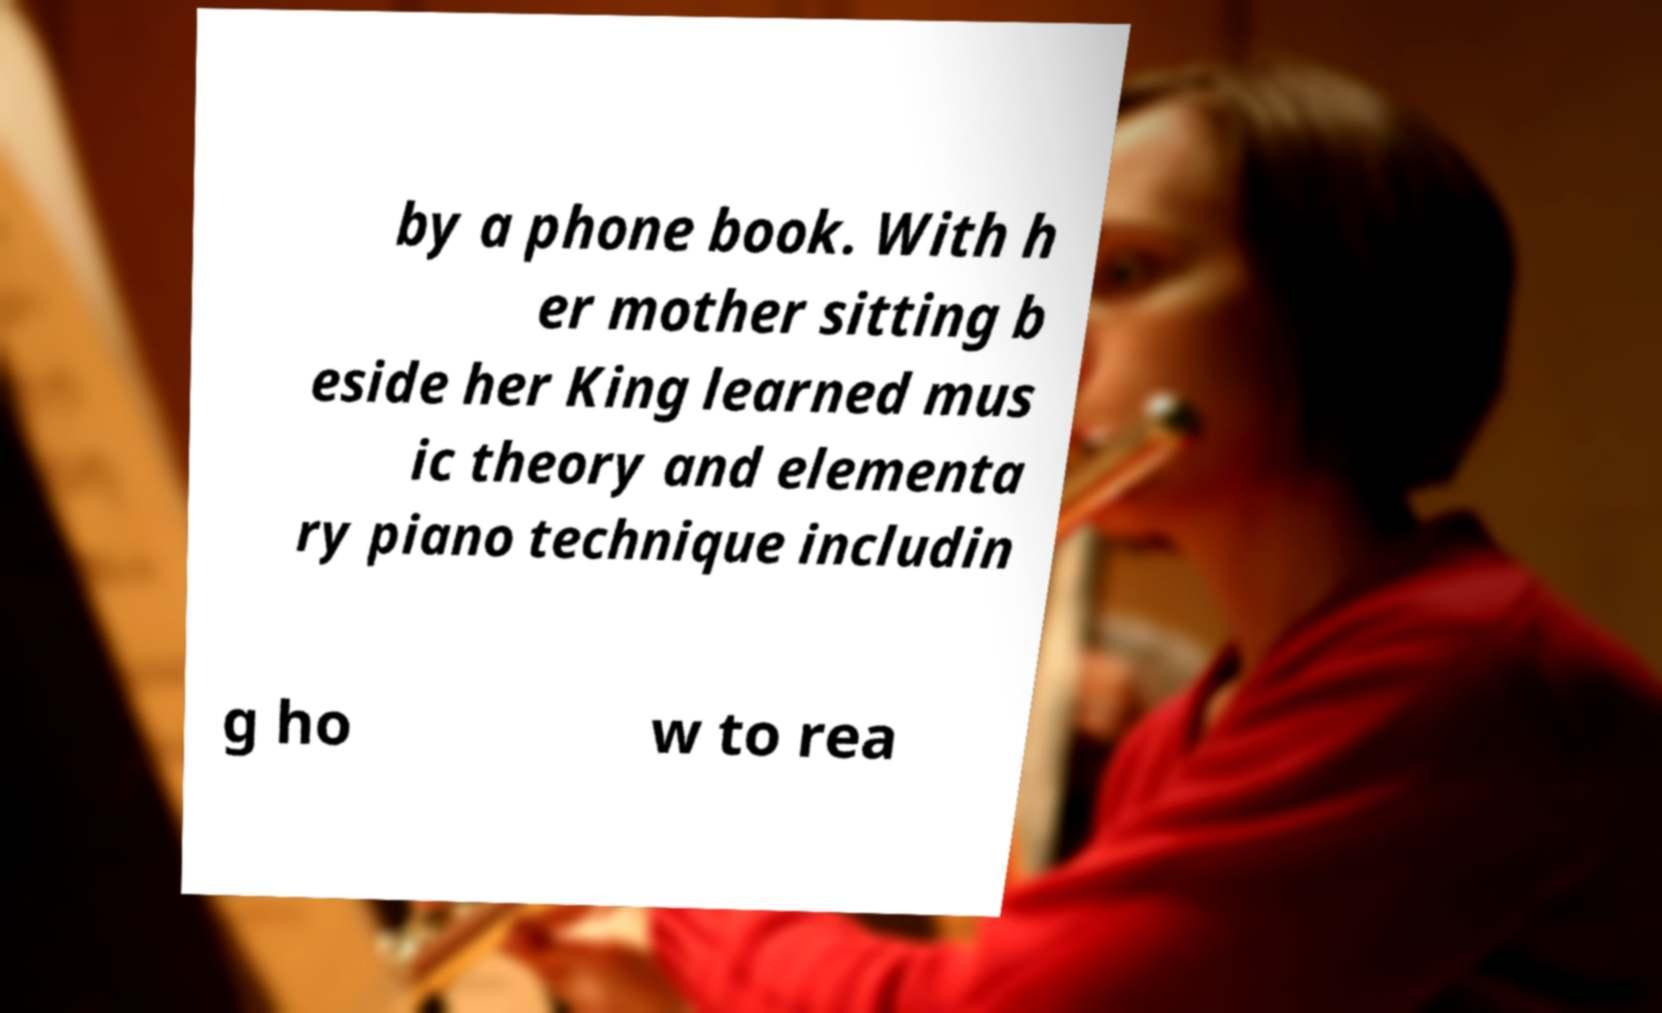There's text embedded in this image that I need extracted. Can you transcribe it verbatim? by a phone book. With h er mother sitting b eside her King learned mus ic theory and elementa ry piano technique includin g ho w to rea 